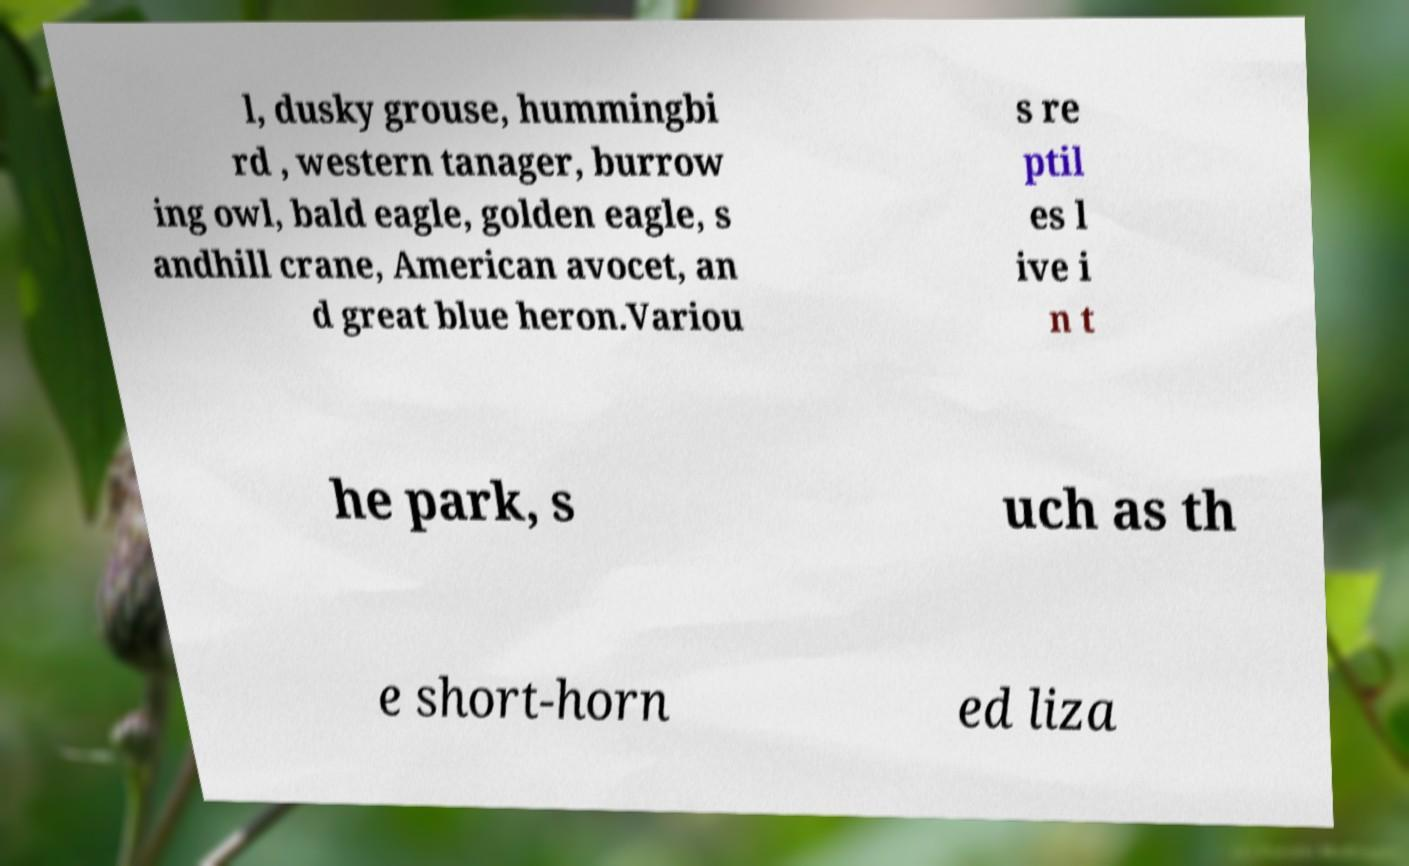I need the written content from this picture converted into text. Can you do that? l, dusky grouse, hummingbi rd , western tanager, burrow ing owl, bald eagle, golden eagle, s andhill crane, American avocet, an d great blue heron.Variou s re ptil es l ive i n t he park, s uch as th e short-horn ed liza 